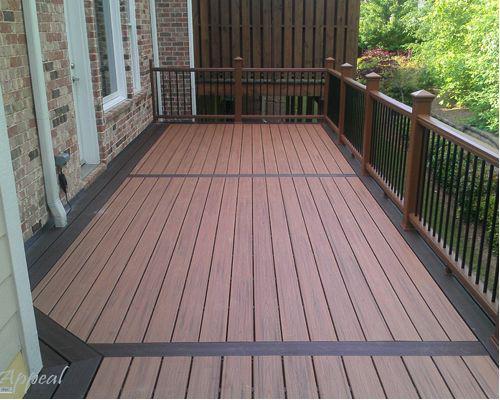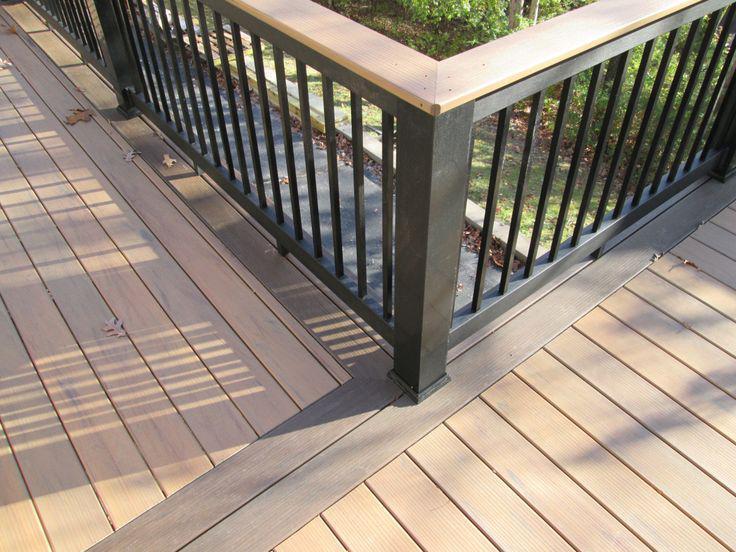The first image is the image on the left, the second image is the image on the right. Evaluate the accuracy of this statement regarding the images: "A wooden deck has bright white rails with black balusters.". Is it true? Answer yes or no. No. The first image is the image on the left, the second image is the image on the right. For the images shown, is this caption "One of the railings is black and white." true? Answer yes or no. No. 